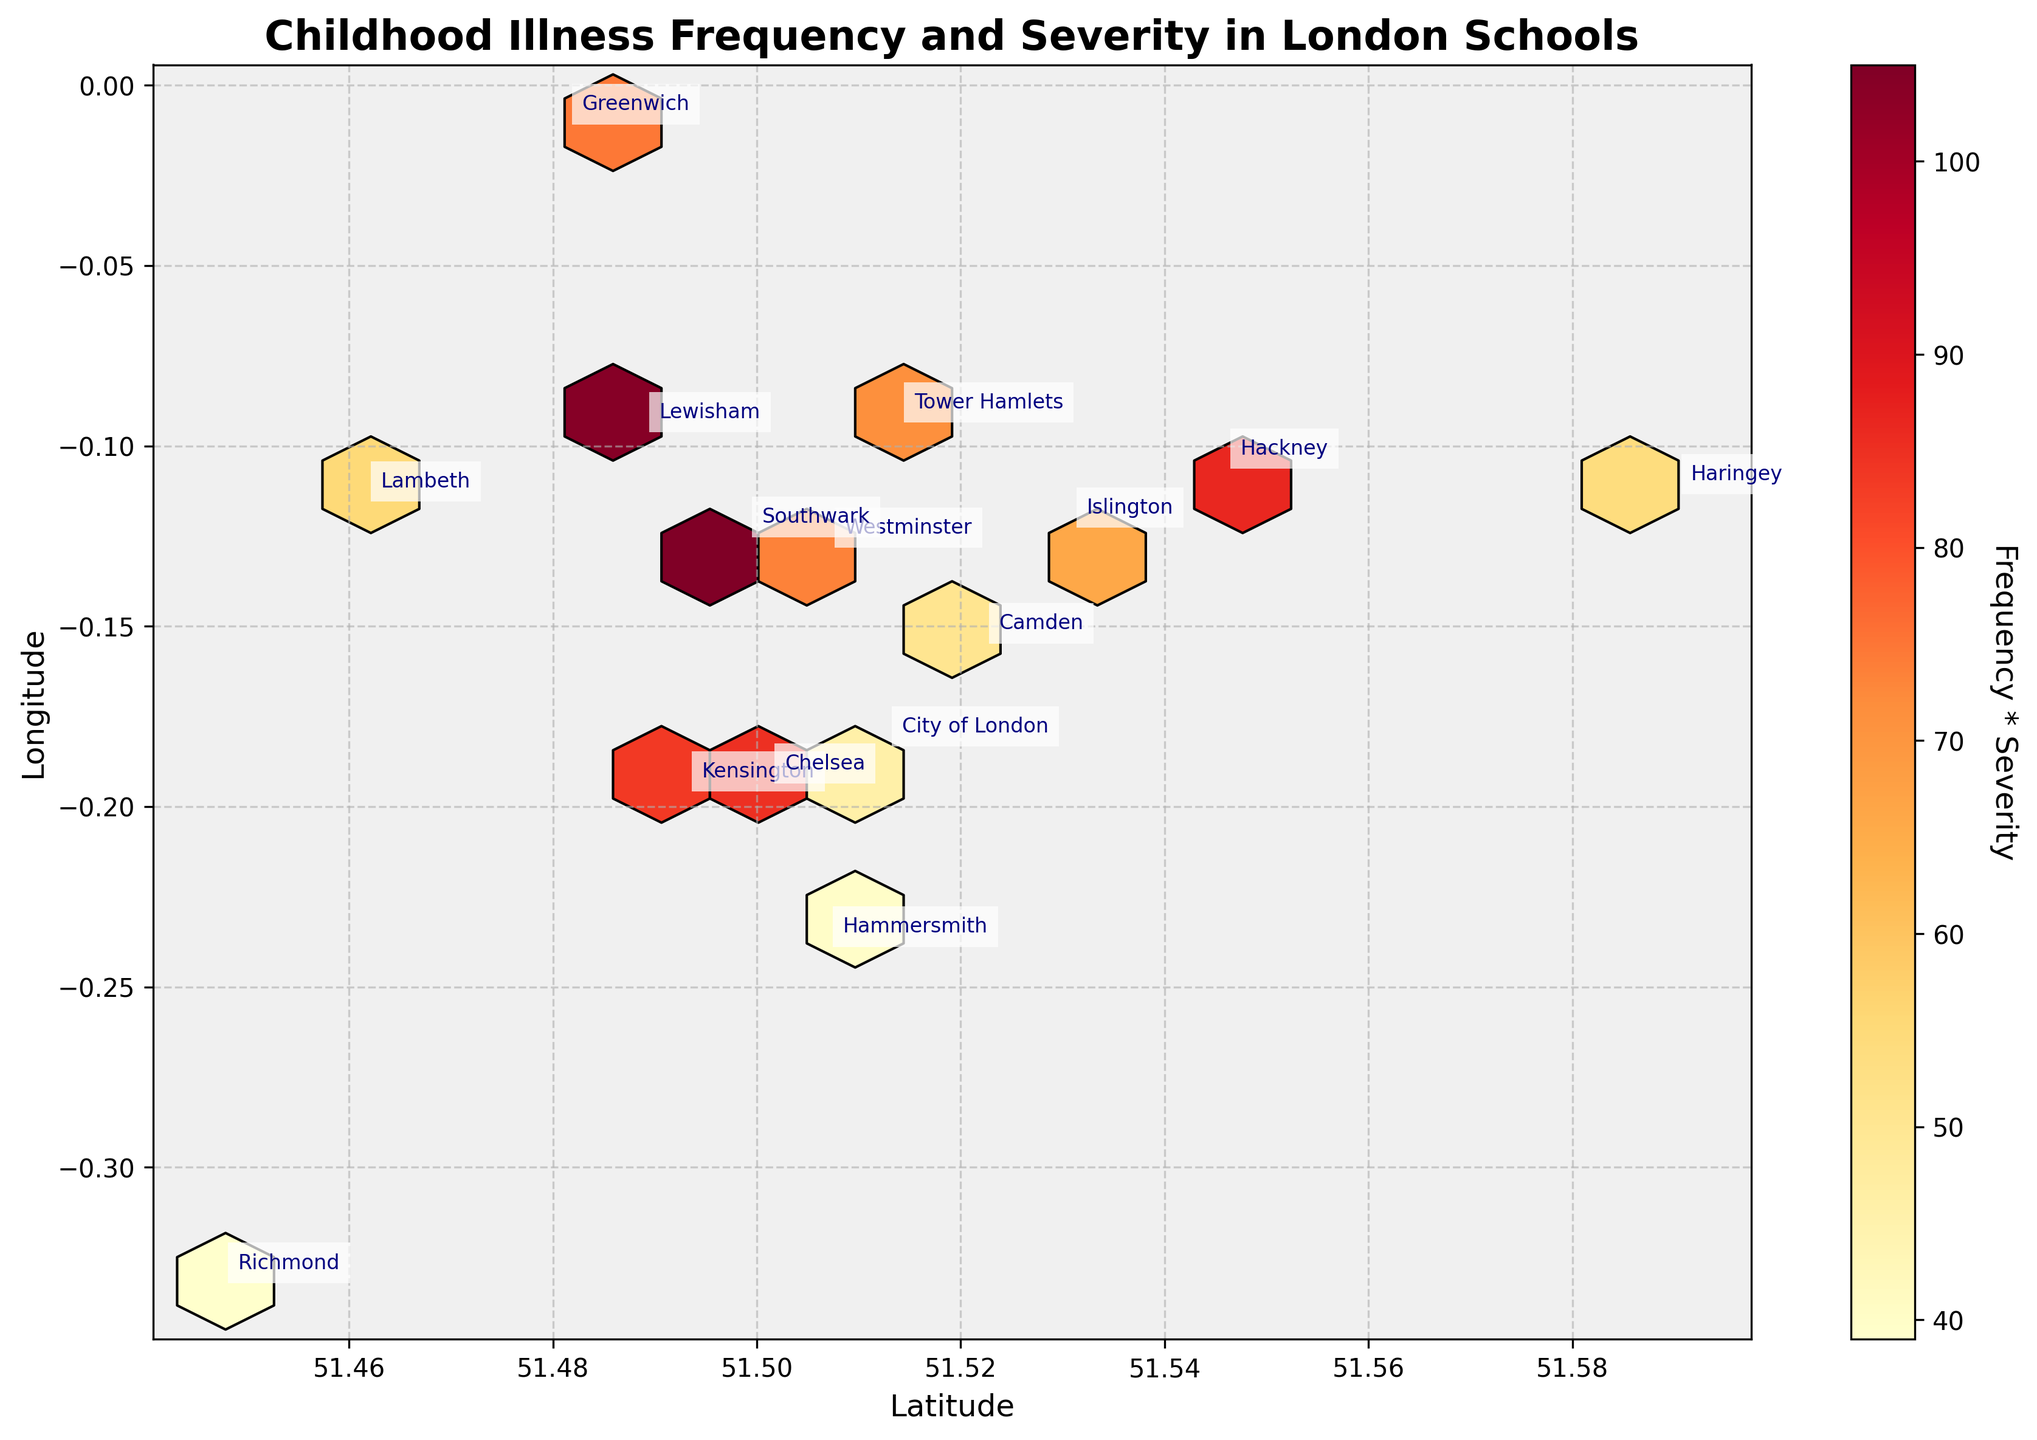What's the title of the figure? The title of the figure is displayed prominently at the top, in bold font. It reads 'Childhood Illness Frequency and Severity in London Schools'.
Answer: Childhood Illness Frequency and Severity in London Schools What are the labels of the x and y axes? The x-axis label, located beneath the horizontal axis, is 'Latitude'. The y-axis label, located beside the vertical axis, is 'Longitude'.
Answer: Latitude and Longitude Which color represents the highest frequency * severity in the hexbin plot? The color bar shows the gradation from lighter to darker colors, with the darkest color indicating the highest value. The darkest color in the plot is reddish-brown.
Answer: Reddish-brown Which neighborhood has the highest position in the plot? By looking at the y-axis (Longitude), the highest position corresponds to the highest latitude value. Haringey appears at the highest position in the plot.
Answer: Haringey Identify the neighborhood with the highest 'Frequency * Severity' product from the plot. The hexbin plot uses color gradients to represent 'Frequency * Severity'. The darkest hexagon close to a neighborhood annotation represents Lewisham. Hence, Lewisham has the highest 'Frequency * Severity'.
Answer: Lewisham Among the seasons depicted, which one appears most frequently among neighborhoods with darker hexagons (indicator of higher 'Frequency * Severity')? Observing both the colors around neighborhood labels and the season mentioned, higher intensity (darker hexagons) is around the 'Spring' season labels (e.g., Lewisham, Camden).
Answer: Spring What is the range of the color bar values? Examining the labels on the color bar, the values range from a lower limit to an upper limit. They are between 20 and 105.
Answer: 20 to 105 Which two neighborhoods appear closest to each other on the plot? Look at neighborhood annotations positioned closely together. Southwark and Lambeth annotations are closest geographically on the plot.
Answer: Southwark and Lambeth What's the relationship between Lambeth and the 'Severity' value in the plot? Checking Lambeth's location, the 'Severity' value multiplied by the frequency places it in a moderately colored hexagon, which implies a moderate 'Severity' value.
Answer: Moderate 